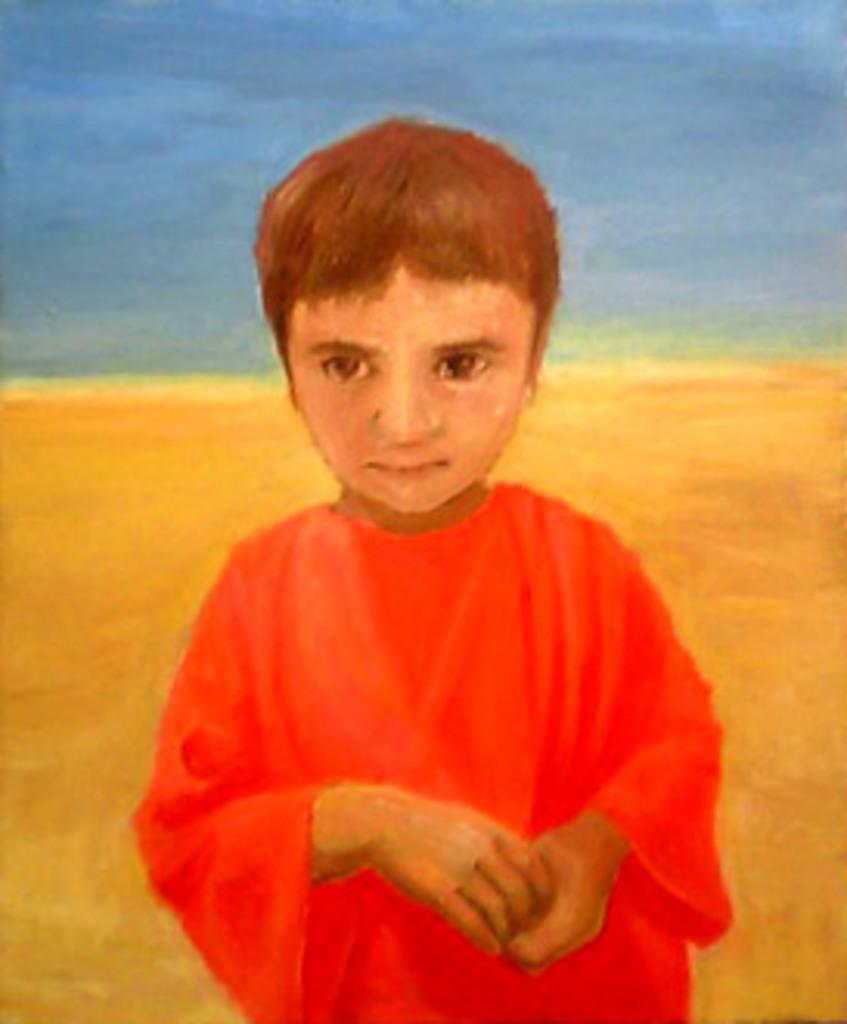What is the main subject of the painting in the image? The painting depicts a boy. What is the boy wearing in the painting? The boy is wearing a red dress in the painting. What colors are used in the background of the painting? The background of the painting includes blue and yellow colors. Can you see a ghost in the painting? There is no ghost present in the painting; it depicts a boy wearing a red dress with a blue and yellow background. Is there a yak in the painting? There is no yak present in the painting; it depicts a boy wearing a red dress with a blue and yellow background. 